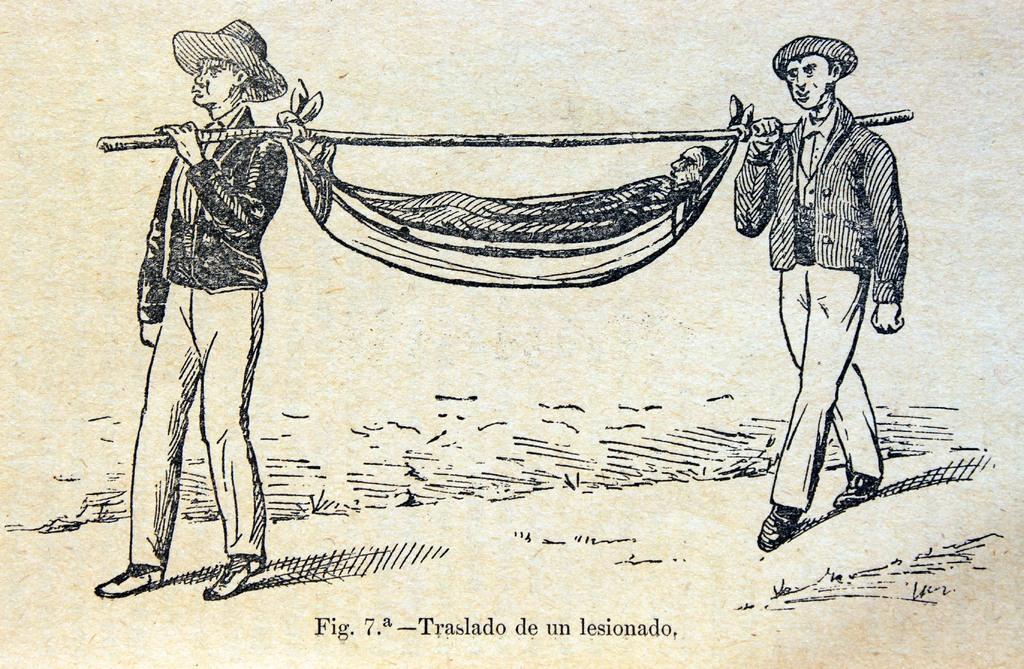In one or two sentences, can you explain what this image depicts? It's an art in this two men are walking and carrying a person to a stick. 